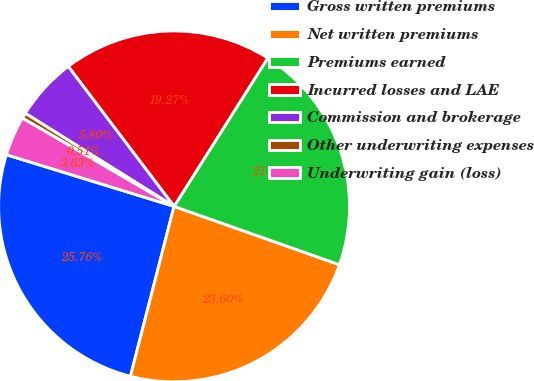Convert chart to OTSL. <chart><loc_0><loc_0><loc_500><loc_500><pie_chart><fcel>Gross written premiums<fcel>Net written premiums<fcel>Premiums earned<fcel>Incurred losses and LAE<fcel>Commission and brokerage<fcel>Other underwriting expenses<fcel>Underwriting gain (loss)<nl><fcel>25.76%<fcel>23.6%<fcel>21.43%<fcel>19.27%<fcel>5.8%<fcel>0.51%<fcel>3.63%<nl></chart> 